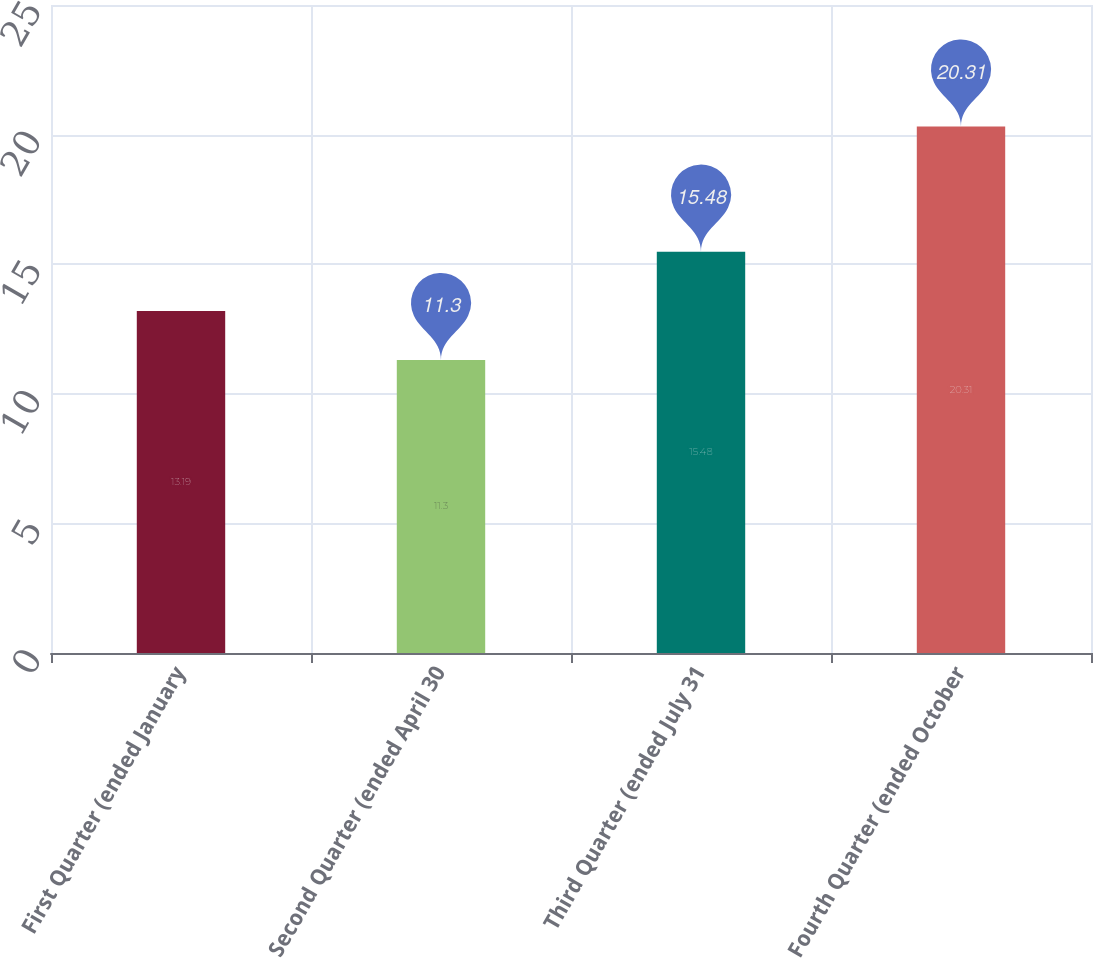Convert chart to OTSL. <chart><loc_0><loc_0><loc_500><loc_500><bar_chart><fcel>First Quarter (ended January<fcel>Second Quarter (ended April 30<fcel>Third Quarter (ended July 31<fcel>Fourth Quarter (ended October<nl><fcel>13.19<fcel>11.3<fcel>15.48<fcel>20.31<nl></chart> 